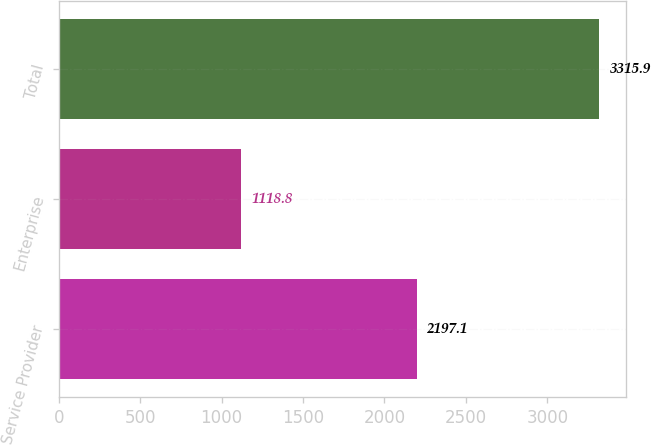Convert chart. <chart><loc_0><loc_0><loc_500><loc_500><bar_chart><fcel>Service Provider<fcel>Enterprise<fcel>Total<nl><fcel>2197.1<fcel>1118.8<fcel>3315.9<nl></chart> 